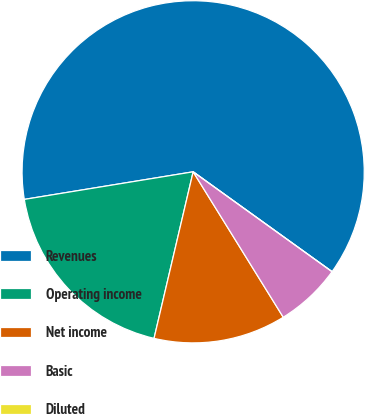<chart> <loc_0><loc_0><loc_500><loc_500><pie_chart><fcel>Revenues<fcel>Operating income<fcel>Net income<fcel>Basic<fcel>Diluted<nl><fcel>62.5%<fcel>18.75%<fcel>12.5%<fcel>6.25%<fcel>0.0%<nl></chart> 